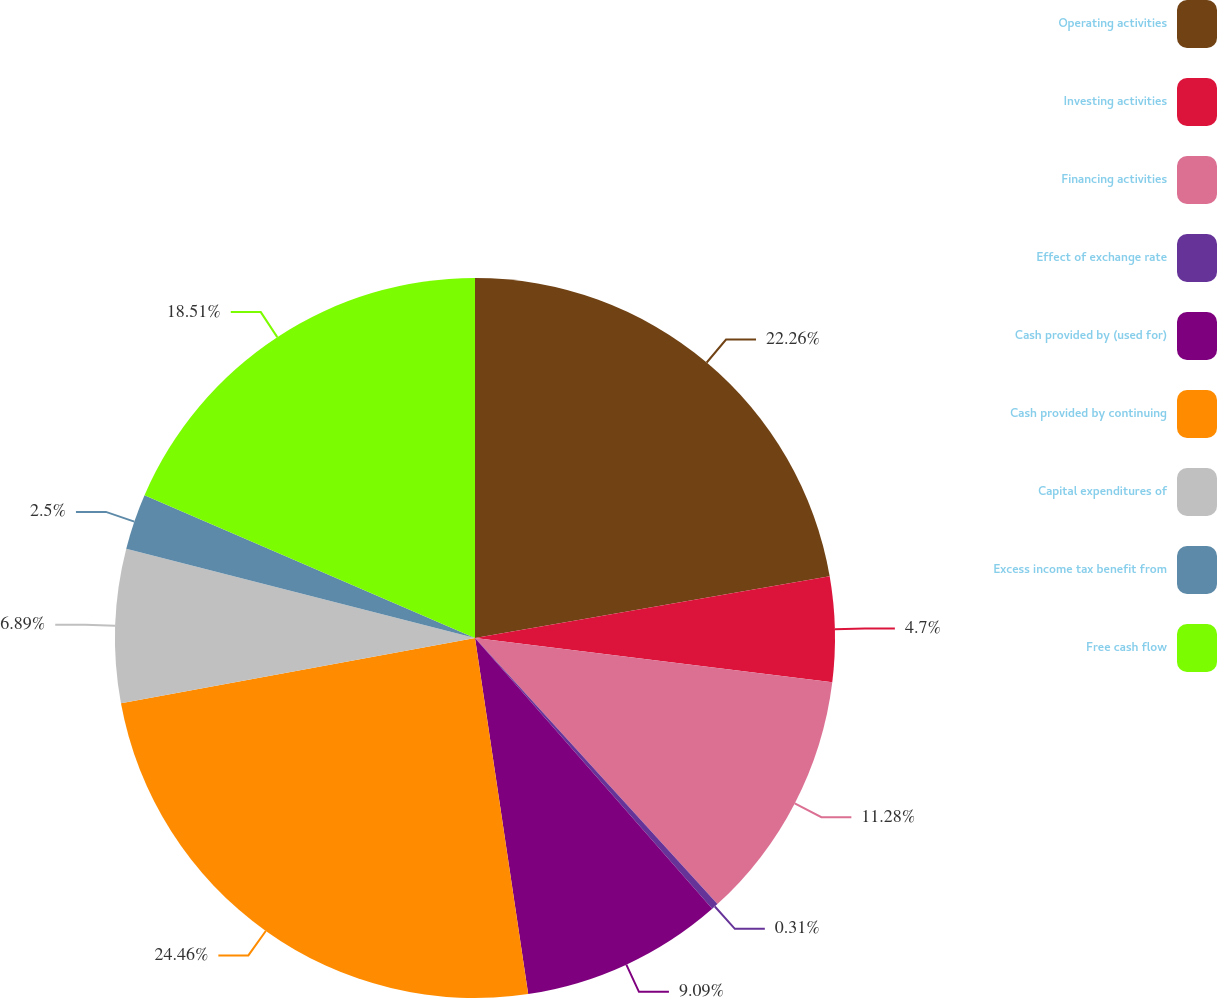<chart> <loc_0><loc_0><loc_500><loc_500><pie_chart><fcel>Operating activities<fcel>Investing activities<fcel>Financing activities<fcel>Effect of exchange rate<fcel>Cash provided by (used for)<fcel>Cash provided by continuing<fcel>Capital expenditures of<fcel>Excess income tax benefit from<fcel>Free cash flow<nl><fcel>22.26%<fcel>4.7%<fcel>11.28%<fcel>0.31%<fcel>9.09%<fcel>24.46%<fcel>6.89%<fcel>2.5%<fcel>18.51%<nl></chart> 